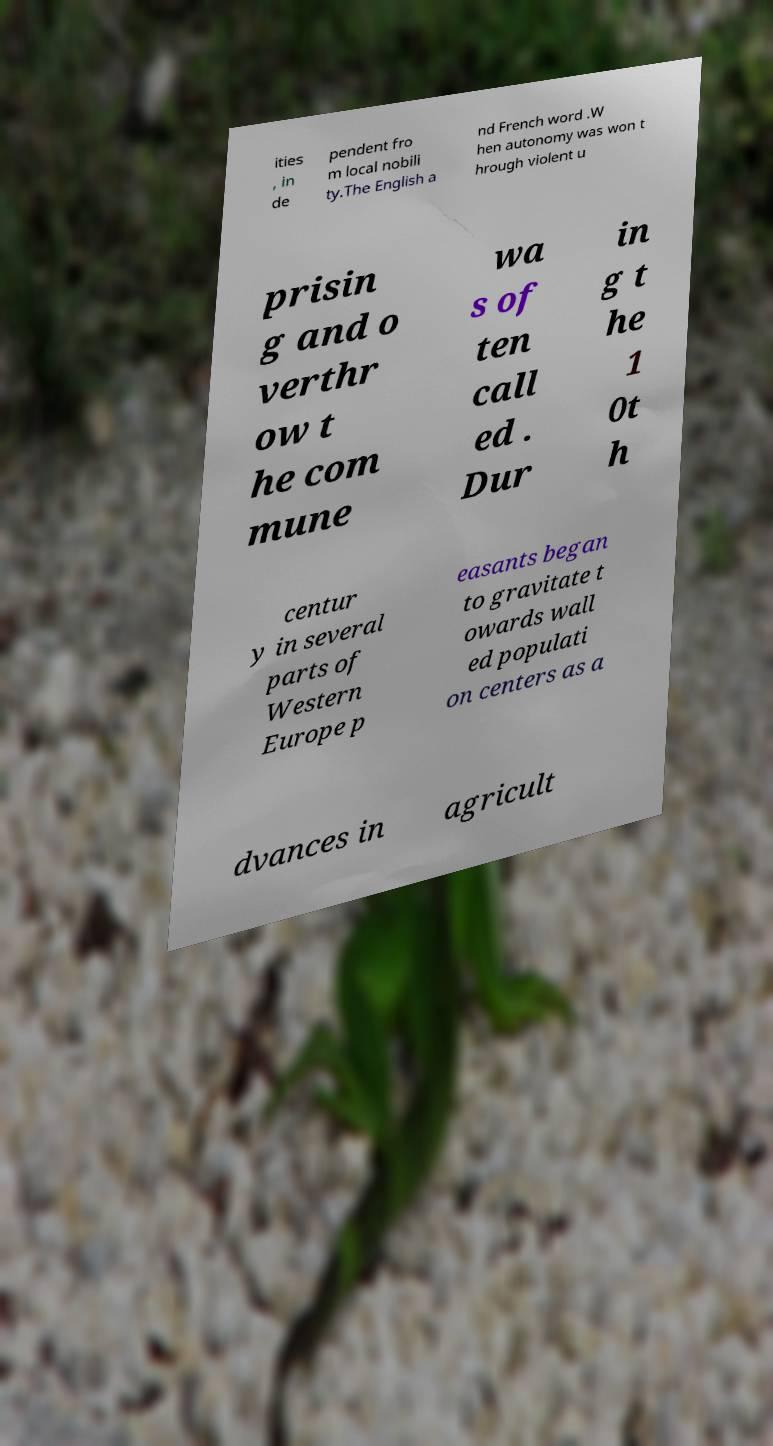Could you assist in decoding the text presented in this image and type it out clearly? ities , in de pendent fro m local nobili ty.The English a nd French word .W hen autonomy was won t hrough violent u prisin g and o verthr ow t he com mune wa s of ten call ed . Dur in g t he 1 0t h centur y in several parts of Western Europe p easants began to gravitate t owards wall ed populati on centers as a dvances in agricult 